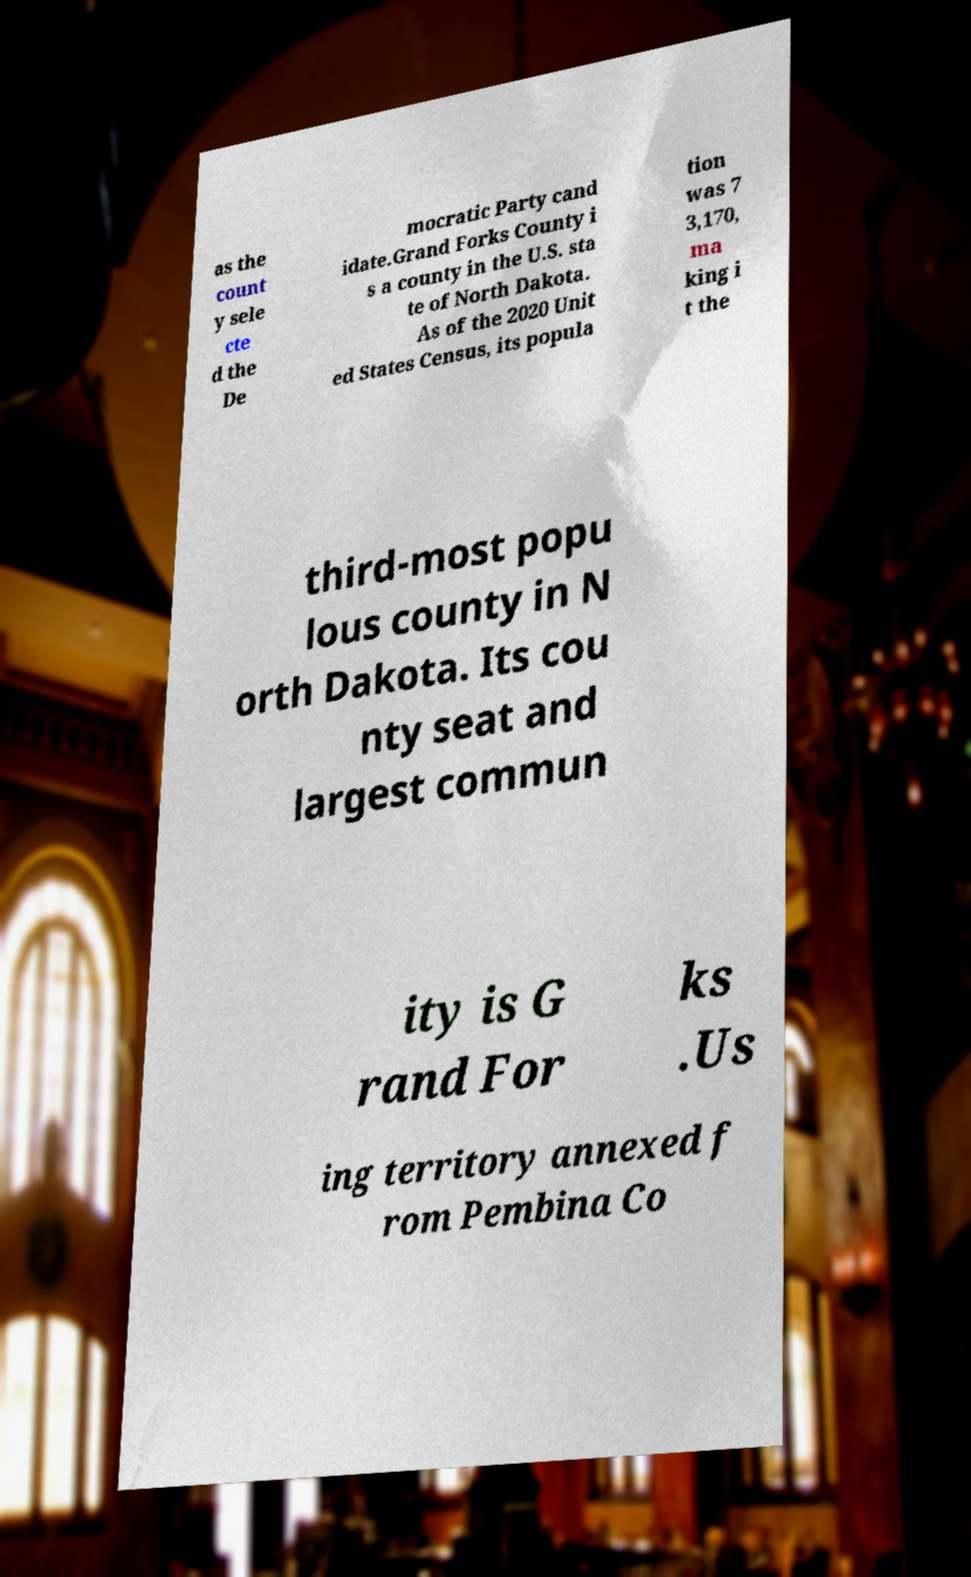Can you accurately transcribe the text from the provided image for me? as the count y sele cte d the De mocratic Party cand idate.Grand Forks County i s a county in the U.S. sta te of North Dakota. As of the 2020 Unit ed States Census, its popula tion was 7 3,170, ma king i t the third-most popu lous county in N orth Dakota. Its cou nty seat and largest commun ity is G rand For ks .Us ing territory annexed f rom Pembina Co 